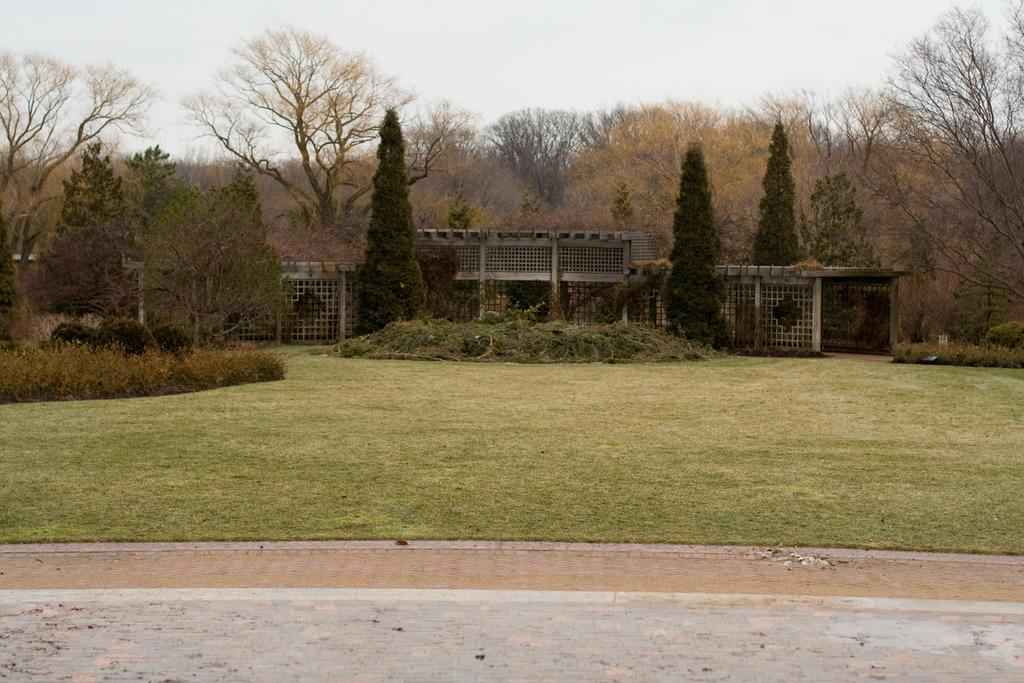What is visible in the foreground of the picture? There is grass, pavement, and dust in the foreground of the picture. What can be seen in the center of the picture? There are trees, plants, a building, and waste in the center of the picture. What is the condition of the sky in the picture? The sky is cloudy in the picture. Where is the mine located in the picture? There is no mine present in the picture. Can you describe the frog sitting on the building in the center of the picture? There is no frog present in the picture; it only features trees, plants, a building, and waste in the center. 